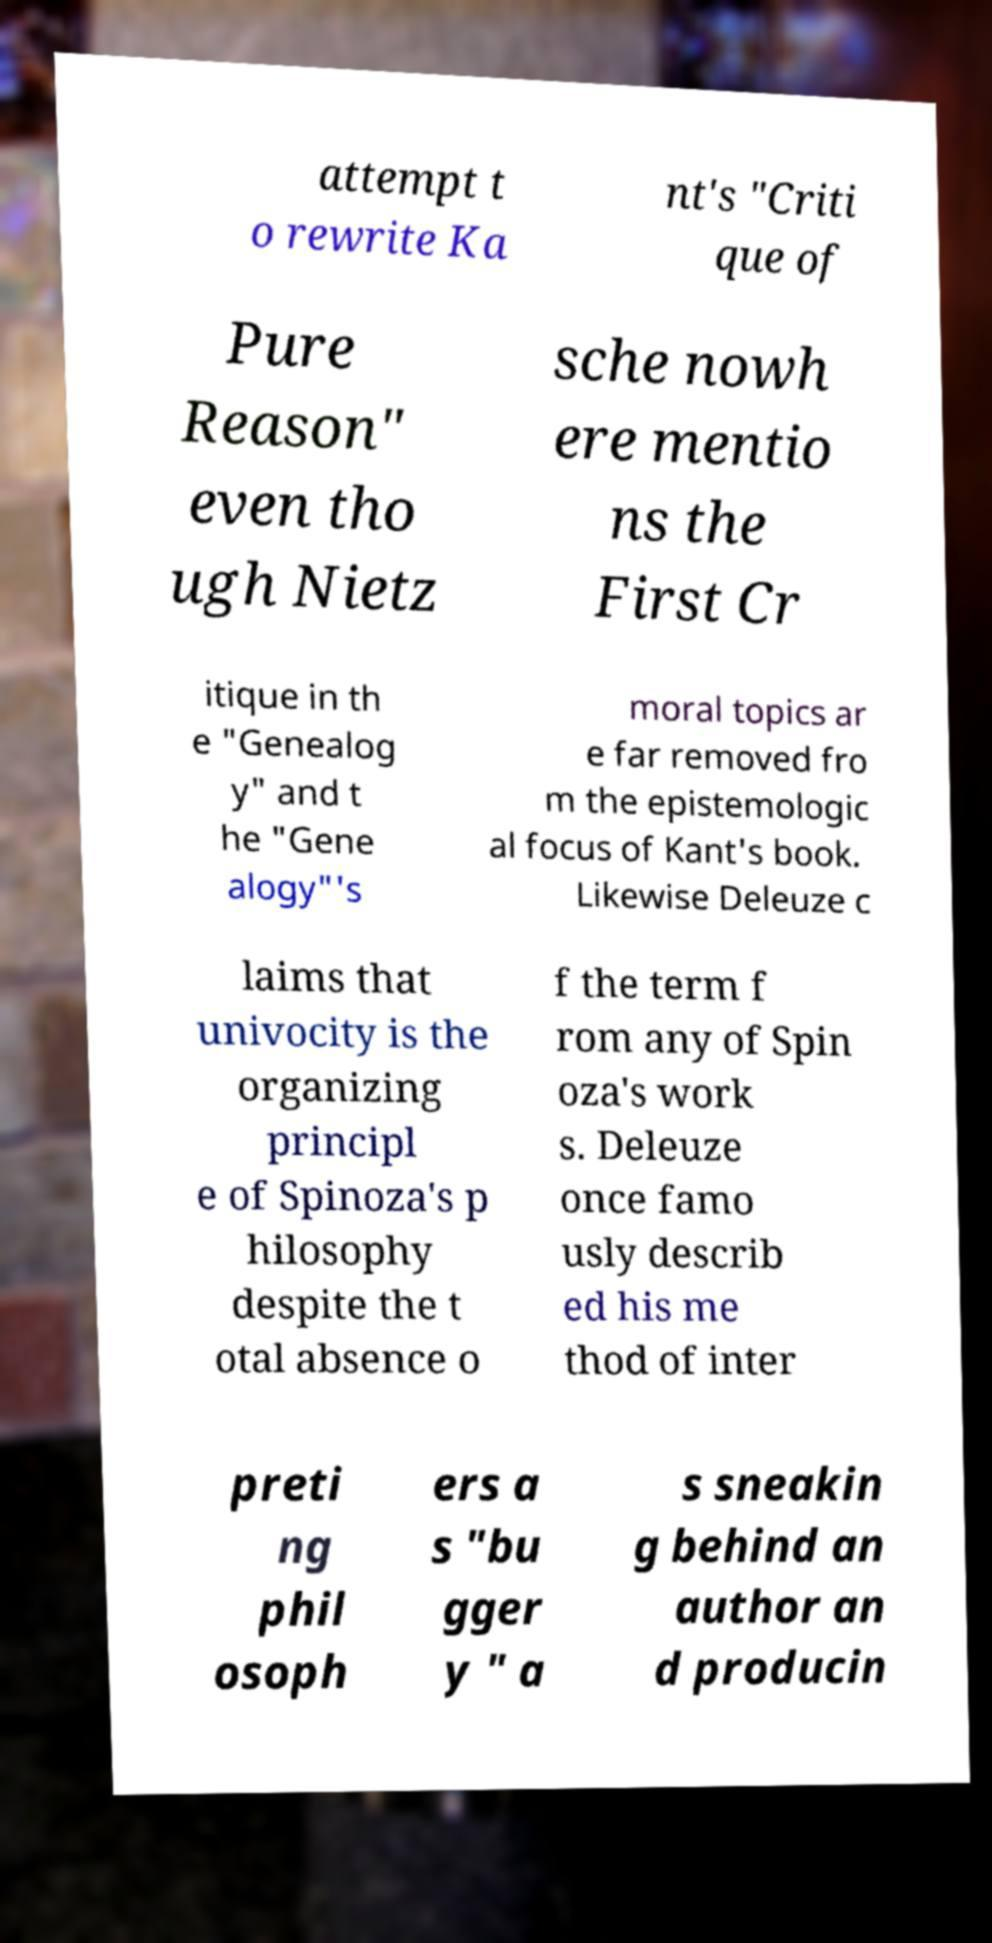Please identify and transcribe the text found in this image. attempt t o rewrite Ka nt's "Criti que of Pure Reason" even tho ugh Nietz sche nowh ere mentio ns the First Cr itique in th e "Genealog y" and t he "Gene alogy"'s moral topics ar e far removed fro m the epistemologic al focus of Kant's book. Likewise Deleuze c laims that univocity is the organizing principl e of Spinoza's p hilosophy despite the t otal absence o f the term f rom any of Spin oza's work s. Deleuze once famo usly describ ed his me thod of inter preti ng phil osoph ers a s "bu gger y " a s sneakin g behind an author an d producin 